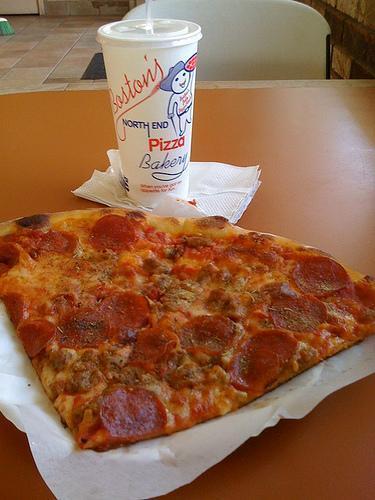How many slices of pizza are there?
Give a very brief answer. 2. 